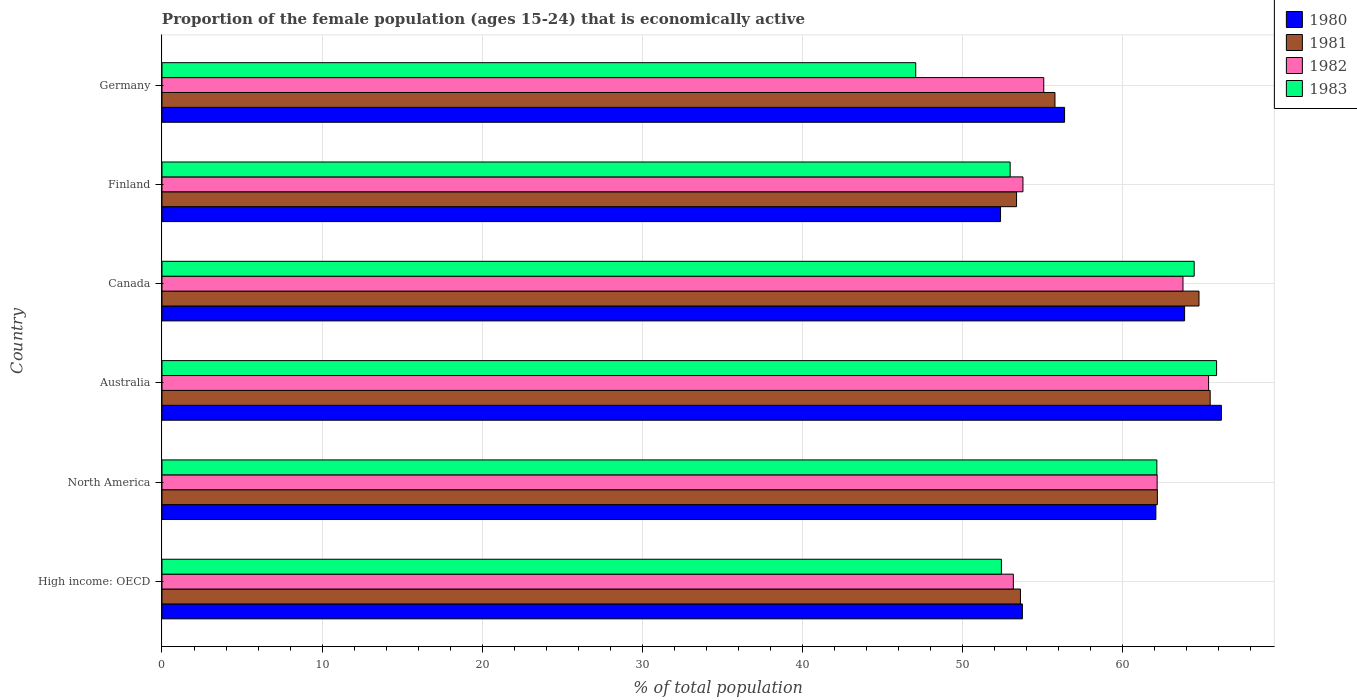How many different coloured bars are there?
Keep it short and to the point. 4. How many groups of bars are there?
Your response must be concise. 6. Are the number of bars per tick equal to the number of legend labels?
Offer a very short reply. Yes. How many bars are there on the 3rd tick from the bottom?
Your answer should be very brief. 4. What is the proportion of the female population that is economically active in 1981 in High income: OECD?
Ensure brevity in your answer.  53.64. Across all countries, what is the maximum proportion of the female population that is economically active in 1982?
Provide a succinct answer. 65.4. Across all countries, what is the minimum proportion of the female population that is economically active in 1983?
Ensure brevity in your answer.  47.1. In which country was the proportion of the female population that is economically active in 1981 maximum?
Provide a short and direct response. Australia. What is the total proportion of the female population that is economically active in 1983 in the graph?
Your answer should be very brief. 345.12. What is the difference between the proportion of the female population that is economically active in 1982 in Canada and that in Germany?
Your answer should be very brief. 8.7. What is the difference between the proportion of the female population that is economically active in 1982 in Finland and the proportion of the female population that is economically active in 1981 in Canada?
Ensure brevity in your answer.  -11. What is the average proportion of the female population that is economically active in 1981 per country?
Your answer should be compact. 59.22. What is the difference between the proportion of the female population that is economically active in 1981 and proportion of the female population that is economically active in 1982 in North America?
Offer a terse response. 0.01. In how many countries, is the proportion of the female population that is economically active in 1983 greater than 32 %?
Make the answer very short. 6. What is the ratio of the proportion of the female population that is economically active in 1980 in High income: OECD to that in North America?
Give a very brief answer. 0.87. What is the difference between the highest and the second highest proportion of the female population that is economically active in 1981?
Your answer should be very brief. 0.7. What is the difference between the highest and the lowest proportion of the female population that is economically active in 1981?
Your answer should be very brief. 12.1. In how many countries, is the proportion of the female population that is economically active in 1983 greater than the average proportion of the female population that is economically active in 1983 taken over all countries?
Provide a succinct answer. 3. What does the 2nd bar from the top in High income: OECD represents?
Your answer should be compact. 1982. How many bars are there?
Provide a succinct answer. 24. Are the values on the major ticks of X-axis written in scientific E-notation?
Provide a succinct answer. No. Does the graph contain any zero values?
Provide a short and direct response. No. What is the title of the graph?
Make the answer very short. Proportion of the female population (ages 15-24) that is economically active. Does "2001" appear as one of the legend labels in the graph?
Keep it short and to the point. No. What is the label or title of the X-axis?
Give a very brief answer. % of total population. What is the label or title of the Y-axis?
Provide a succinct answer. Country. What is the % of total population in 1980 in High income: OECD?
Provide a succinct answer. 53.76. What is the % of total population in 1981 in High income: OECD?
Your answer should be very brief. 53.64. What is the % of total population in 1982 in High income: OECD?
Give a very brief answer. 53.2. What is the % of total population of 1983 in High income: OECD?
Offer a very short reply. 52.45. What is the % of total population of 1980 in North America?
Offer a terse response. 62.11. What is the % of total population in 1981 in North America?
Provide a succinct answer. 62.2. What is the % of total population in 1982 in North America?
Ensure brevity in your answer.  62.19. What is the % of total population in 1983 in North America?
Give a very brief answer. 62.17. What is the % of total population of 1980 in Australia?
Your answer should be very brief. 66.2. What is the % of total population in 1981 in Australia?
Your response must be concise. 65.5. What is the % of total population in 1982 in Australia?
Offer a terse response. 65.4. What is the % of total population of 1983 in Australia?
Your answer should be very brief. 65.9. What is the % of total population in 1980 in Canada?
Give a very brief answer. 63.9. What is the % of total population of 1981 in Canada?
Your answer should be compact. 64.8. What is the % of total population of 1982 in Canada?
Provide a succinct answer. 63.8. What is the % of total population of 1983 in Canada?
Provide a succinct answer. 64.5. What is the % of total population in 1980 in Finland?
Provide a succinct answer. 52.4. What is the % of total population of 1981 in Finland?
Offer a very short reply. 53.4. What is the % of total population of 1982 in Finland?
Your answer should be very brief. 53.8. What is the % of total population in 1980 in Germany?
Offer a very short reply. 56.4. What is the % of total population of 1981 in Germany?
Give a very brief answer. 55.8. What is the % of total population in 1982 in Germany?
Offer a very short reply. 55.1. What is the % of total population of 1983 in Germany?
Ensure brevity in your answer.  47.1. Across all countries, what is the maximum % of total population in 1980?
Your answer should be very brief. 66.2. Across all countries, what is the maximum % of total population of 1981?
Ensure brevity in your answer.  65.5. Across all countries, what is the maximum % of total population of 1982?
Provide a succinct answer. 65.4. Across all countries, what is the maximum % of total population in 1983?
Make the answer very short. 65.9. Across all countries, what is the minimum % of total population in 1980?
Your answer should be very brief. 52.4. Across all countries, what is the minimum % of total population of 1981?
Make the answer very short. 53.4. Across all countries, what is the minimum % of total population of 1982?
Your answer should be compact. 53.2. Across all countries, what is the minimum % of total population of 1983?
Keep it short and to the point. 47.1. What is the total % of total population in 1980 in the graph?
Ensure brevity in your answer.  354.77. What is the total % of total population of 1981 in the graph?
Offer a terse response. 355.34. What is the total % of total population in 1982 in the graph?
Give a very brief answer. 353.48. What is the total % of total population in 1983 in the graph?
Your response must be concise. 345.12. What is the difference between the % of total population of 1980 in High income: OECD and that in North America?
Offer a terse response. -8.34. What is the difference between the % of total population of 1981 in High income: OECD and that in North America?
Make the answer very short. -8.56. What is the difference between the % of total population of 1982 in High income: OECD and that in North America?
Provide a short and direct response. -8.99. What is the difference between the % of total population of 1983 in High income: OECD and that in North America?
Ensure brevity in your answer.  -9.71. What is the difference between the % of total population in 1980 in High income: OECD and that in Australia?
Ensure brevity in your answer.  -12.44. What is the difference between the % of total population in 1981 in High income: OECD and that in Australia?
Your answer should be very brief. -11.86. What is the difference between the % of total population in 1982 in High income: OECD and that in Australia?
Offer a terse response. -12.2. What is the difference between the % of total population in 1983 in High income: OECD and that in Australia?
Provide a short and direct response. -13.45. What is the difference between the % of total population of 1980 in High income: OECD and that in Canada?
Ensure brevity in your answer.  -10.14. What is the difference between the % of total population in 1981 in High income: OECD and that in Canada?
Offer a terse response. -11.16. What is the difference between the % of total population in 1982 in High income: OECD and that in Canada?
Provide a short and direct response. -10.6. What is the difference between the % of total population in 1983 in High income: OECD and that in Canada?
Keep it short and to the point. -12.05. What is the difference between the % of total population of 1980 in High income: OECD and that in Finland?
Offer a very short reply. 1.36. What is the difference between the % of total population in 1981 in High income: OECD and that in Finland?
Offer a terse response. 0.24. What is the difference between the % of total population in 1982 in High income: OECD and that in Finland?
Give a very brief answer. -0.6. What is the difference between the % of total population in 1983 in High income: OECD and that in Finland?
Offer a very short reply. -0.55. What is the difference between the % of total population of 1980 in High income: OECD and that in Germany?
Your answer should be very brief. -2.64. What is the difference between the % of total population of 1981 in High income: OECD and that in Germany?
Provide a short and direct response. -2.16. What is the difference between the % of total population of 1982 in High income: OECD and that in Germany?
Ensure brevity in your answer.  -1.9. What is the difference between the % of total population in 1983 in High income: OECD and that in Germany?
Offer a terse response. 5.35. What is the difference between the % of total population in 1980 in North America and that in Australia?
Your answer should be very brief. -4.09. What is the difference between the % of total population in 1981 in North America and that in Australia?
Offer a very short reply. -3.3. What is the difference between the % of total population of 1982 in North America and that in Australia?
Provide a short and direct response. -3.21. What is the difference between the % of total population of 1983 in North America and that in Australia?
Provide a short and direct response. -3.73. What is the difference between the % of total population of 1980 in North America and that in Canada?
Your answer should be compact. -1.79. What is the difference between the % of total population in 1981 in North America and that in Canada?
Make the answer very short. -2.6. What is the difference between the % of total population of 1982 in North America and that in Canada?
Your response must be concise. -1.61. What is the difference between the % of total population of 1983 in North America and that in Canada?
Your answer should be very brief. -2.33. What is the difference between the % of total population in 1980 in North America and that in Finland?
Ensure brevity in your answer.  9.71. What is the difference between the % of total population in 1981 in North America and that in Finland?
Offer a very short reply. 8.8. What is the difference between the % of total population in 1982 in North America and that in Finland?
Your response must be concise. 8.39. What is the difference between the % of total population of 1983 in North America and that in Finland?
Provide a succinct answer. 9.17. What is the difference between the % of total population in 1980 in North America and that in Germany?
Your answer should be very brief. 5.71. What is the difference between the % of total population of 1981 in North America and that in Germany?
Make the answer very short. 6.4. What is the difference between the % of total population of 1982 in North America and that in Germany?
Your answer should be very brief. 7.09. What is the difference between the % of total population in 1983 in North America and that in Germany?
Offer a very short reply. 15.07. What is the difference between the % of total population in 1980 in Australia and that in Canada?
Offer a terse response. 2.3. What is the difference between the % of total population of 1982 in Australia and that in Canada?
Offer a terse response. 1.6. What is the difference between the % of total population in 1981 in Australia and that in Finland?
Ensure brevity in your answer.  12.1. What is the difference between the % of total population in 1982 in Australia and that in Finland?
Offer a terse response. 11.6. What is the difference between the % of total population in 1980 in Australia and that in Germany?
Keep it short and to the point. 9.8. What is the difference between the % of total population of 1983 in Australia and that in Germany?
Make the answer very short. 18.8. What is the difference between the % of total population in 1980 in Canada and that in Finland?
Ensure brevity in your answer.  11.5. What is the difference between the % of total population in 1983 in Canada and that in Finland?
Make the answer very short. 11.5. What is the difference between the % of total population of 1981 in Canada and that in Germany?
Make the answer very short. 9. What is the difference between the % of total population in 1982 in Canada and that in Germany?
Your answer should be compact. 8.7. What is the difference between the % of total population in 1983 in Canada and that in Germany?
Offer a terse response. 17.4. What is the difference between the % of total population of 1982 in Finland and that in Germany?
Make the answer very short. -1.3. What is the difference between the % of total population of 1980 in High income: OECD and the % of total population of 1981 in North America?
Keep it short and to the point. -8.44. What is the difference between the % of total population of 1980 in High income: OECD and the % of total population of 1982 in North America?
Provide a succinct answer. -8.42. What is the difference between the % of total population in 1980 in High income: OECD and the % of total population in 1983 in North America?
Keep it short and to the point. -8.4. What is the difference between the % of total population in 1981 in High income: OECD and the % of total population in 1982 in North America?
Ensure brevity in your answer.  -8.54. What is the difference between the % of total population of 1981 in High income: OECD and the % of total population of 1983 in North America?
Your answer should be compact. -8.52. What is the difference between the % of total population in 1982 in High income: OECD and the % of total population in 1983 in North America?
Keep it short and to the point. -8.97. What is the difference between the % of total population of 1980 in High income: OECD and the % of total population of 1981 in Australia?
Make the answer very short. -11.74. What is the difference between the % of total population of 1980 in High income: OECD and the % of total population of 1982 in Australia?
Offer a very short reply. -11.64. What is the difference between the % of total population of 1980 in High income: OECD and the % of total population of 1983 in Australia?
Keep it short and to the point. -12.14. What is the difference between the % of total population of 1981 in High income: OECD and the % of total population of 1982 in Australia?
Your answer should be compact. -11.76. What is the difference between the % of total population of 1981 in High income: OECD and the % of total population of 1983 in Australia?
Your answer should be very brief. -12.26. What is the difference between the % of total population in 1982 in High income: OECD and the % of total population in 1983 in Australia?
Offer a terse response. -12.7. What is the difference between the % of total population in 1980 in High income: OECD and the % of total population in 1981 in Canada?
Provide a short and direct response. -11.04. What is the difference between the % of total population in 1980 in High income: OECD and the % of total population in 1982 in Canada?
Your response must be concise. -10.04. What is the difference between the % of total population of 1980 in High income: OECD and the % of total population of 1983 in Canada?
Offer a terse response. -10.74. What is the difference between the % of total population in 1981 in High income: OECD and the % of total population in 1982 in Canada?
Give a very brief answer. -10.16. What is the difference between the % of total population in 1981 in High income: OECD and the % of total population in 1983 in Canada?
Ensure brevity in your answer.  -10.86. What is the difference between the % of total population in 1982 in High income: OECD and the % of total population in 1983 in Canada?
Your answer should be very brief. -11.3. What is the difference between the % of total population of 1980 in High income: OECD and the % of total population of 1981 in Finland?
Your answer should be compact. 0.36. What is the difference between the % of total population of 1980 in High income: OECD and the % of total population of 1982 in Finland?
Your answer should be very brief. -0.04. What is the difference between the % of total population in 1980 in High income: OECD and the % of total population in 1983 in Finland?
Provide a succinct answer. 0.76. What is the difference between the % of total population in 1981 in High income: OECD and the % of total population in 1982 in Finland?
Make the answer very short. -0.16. What is the difference between the % of total population in 1981 in High income: OECD and the % of total population in 1983 in Finland?
Provide a short and direct response. 0.64. What is the difference between the % of total population in 1982 in High income: OECD and the % of total population in 1983 in Finland?
Provide a short and direct response. 0.2. What is the difference between the % of total population in 1980 in High income: OECD and the % of total population in 1981 in Germany?
Offer a terse response. -2.04. What is the difference between the % of total population in 1980 in High income: OECD and the % of total population in 1982 in Germany?
Offer a terse response. -1.34. What is the difference between the % of total population in 1980 in High income: OECD and the % of total population in 1983 in Germany?
Give a very brief answer. 6.66. What is the difference between the % of total population of 1981 in High income: OECD and the % of total population of 1982 in Germany?
Give a very brief answer. -1.46. What is the difference between the % of total population of 1981 in High income: OECD and the % of total population of 1983 in Germany?
Ensure brevity in your answer.  6.54. What is the difference between the % of total population of 1982 in High income: OECD and the % of total population of 1983 in Germany?
Provide a short and direct response. 6.1. What is the difference between the % of total population in 1980 in North America and the % of total population in 1981 in Australia?
Provide a short and direct response. -3.39. What is the difference between the % of total population in 1980 in North America and the % of total population in 1982 in Australia?
Provide a succinct answer. -3.29. What is the difference between the % of total population in 1980 in North America and the % of total population in 1983 in Australia?
Provide a succinct answer. -3.79. What is the difference between the % of total population of 1981 in North America and the % of total population of 1982 in Australia?
Keep it short and to the point. -3.2. What is the difference between the % of total population in 1981 in North America and the % of total population in 1983 in Australia?
Offer a very short reply. -3.7. What is the difference between the % of total population in 1982 in North America and the % of total population in 1983 in Australia?
Provide a short and direct response. -3.71. What is the difference between the % of total population of 1980 in North America and the % of total population of 1981 in Canada?
Ensure brevity in your answer.  -2.69. What is the difference between the % of total population of 1980 in North America and the % of total population of 1982 in Canada?
Ensure brevity in your answer.  -1.69. What is the difference between the % of total population of 1980 in North America and the % of total population of 1983 in Canada?
Offer a terse response. -2.39. What is the difference between the % of total population in 1981 in North America and the % of total population in 1982 in Canada?
Your answer should be very brief. -1.6. What is the difference between the % of total population of 1981 in North America and the % of total population of 1983 in Canada?
Give a very brief answer. -2.3. What is the difference between the % of total population in 1982 in North America and the % of total population in 1983 in Canada?
Offer a terse response. -2.31. What is the difference between the % of total population in 1980 in North America and the % of total population in 1981 in Finland?
Your response must be concise. 8.71. What is the difference between the % of total population of 1980 in North America and the % of total population of 1982 in Finland?
Provide a succinct answer. 8.31. What is the difference between the % of total population in 1980 in North America and the % of total population in 1983 in Finland?
Provide a short and direct response. 9.11. What is the difference between the % of total population of 1981 in North America and the % of total population of 1982 in Finland?
Your response must be concise. 8.4. What is the difference between the % of total population in 1981 in North America and the % of total population in 1983 in Finland?
Offer a very short reply. 9.2. What is the difference between the % of total population of 1982 in North America and the % of total population of 1983 in Finland?
Ensure brevity in your answer.  9.19. What is the difference between the % of total population in 1980 in North America and the % of total population in 1981 in Germany?
Ensure brevity in your answer.  6.31. What is the difference between the % of total population in 1980 in North America and the % of total population in 1982 in Germany?
Offer a very short reply. 7.01. What is the difference between the % of total population of 1980 in North America and the % of total population of 1983 in Germany?
Your response must be concise. 15.01. What is the difference between the % of total population of 1981 in North America and the % of total population of 1982 in Germany?
Give a very brief answer. 7.1. What is the difference between the % of total population of 1981 in North America and the % of total population of 1983 in Germany?
Provide a short and direct response. 15.1. What is the difference between the % of total population in 1982 in North America and the % of total population in 1983 in Germany?
Keep it short and to the point. 15.09. What is the difference between the % of total population of 1981 in Australia and the % of total population of 1982 in Canada?
Provide a short and direct response. 1.7. What is the difference between the % of total population of 1981 in Australia and the % of total population of 1983 in Canada?
Give a very brief answer. 1. What is the difference between the % of total population in 1981 in Australia and the % of total population in 1982 in Finland?
Provide a short and direct response. 11.7. What is the difference between the % of total population of 1981 in Australia and the % of total population of 1983 in Finland?
Offer a very short reply. 12.5. What is the difference between the % of total population in 1982 in Australia and the % of total population in 1983 in Finland?
Provide a succinct answer. 12.4. What is the difference between the % of total population of 1980 in Australia and the % of total population of 1981 in Germany?
Your answer should be very brief. 10.4. What is the difference between the % of total population of 1981 in Australia and the % of total population of 1983 in Germany?
Give a very brief answer. 18.4. What is the difference between the % of total population of 1982 in Australia and the % of total population of 1983 in Germany?
Provide a short and direct response. 18.3. What is the difference between the % of total population of 1980 in Canada and the % of total population of 1981 in Finland?
Keep it short and to the point. 10.5. What is the difference between the % of total population of 1980 in Canada and the % of total population of 1982 in Finland?
Your answer should be very brief. 10.1. What is the difference between the % of total population in 1980 in Canada and the % of total population in 1983 in Finland?
Offer a terse response. 10.9. What is the difference between the % of total population in 1980 in Canada and the % of total population in 1982 in Germany?
Make the answer very short. 8.8. What is the difference between the % of total population in 1980 in Canada and the % of total population in 1983 in Germany?
Offer a very short reply. 16.8. What is the difference between the % of total population in 1981 in Canada and the % of total population in 1982 in Germany?
Your answer should be compact. 9.7. What is the difference between the % of total population of 1982 in Canada and the % of total population of 1983 in Germany?
Provide a succinct answer. 16.7. What is the difference between the % of total population in 1981 in Finland and the % of total population in 1983 in Germany?
Offer a very short reply. 6.3. What is the average % of total population of 1980 per country?
Ensure brevity in your answer.  59.13. What is the average % of total population of 1981 per country?
Offer a terse response. 59.22. What is the average % of total population of 1982 per country?
Your response must be concise. 58.91. What is the average % of total population in 1983 per country?
Your answer should be very brief. 57.52. What is the difference between the % of total population in 1980 and % of total population in 1981 in High income: OECD?
Give a very brief answer. 0.12. What is the difference between the % of total population in 1980 and % of total population in 1982 in High income: OECD?
Offer a terse response. 0.57. What is the difference between the % of total population in 1980 and % of total population in 1983 in High income: OECD?
Give a very brief answer. 1.31. What is the difference between the % of total population of 1981 and % of total population of 1982 in High income: OECD?
Offer a terse response. 0.44. What is the difference between the % of total population in 1981 and % of total population in 1983 in High income: OECD?
Offer a terse response. 1.19. What is the difference between the % of total population in 1982 and % of total population in 1983 in High income: OECD?
Make the answer very short. 0.75. What is the difference between the % of total population in 1980 and % of total population in 1981 in North America?
Keep it short and to the point. -0.09. What is the difference between the % of total population in 1980 and % of total population in 1982 in North America?
Ensure brevity in your answer.  -0.08. What is the difference between the % of total population in 1980 and % of total population in 1983 in North America?
Keep it short and to the point. -0.06. What is the difference between the % of total population in 1981 and % of total population in 1982 in North America?
Your response must be concise. 0.01. What is the difference between the % of total population in 1981 and % of total population in 1983 in North America?
Offer a terse response. 0.03. What is the difference between the % of total population in 1982 and % of total population in 1983 in North America?
Make the answer very short. 0.02. What is the difference between the % of total population in 1980 and % of total population in 1981 in Australia?
Provide a short and direct response. 0.7. What is the difference between the % of total population of 1980 and % of total population of 1982 in Australia?
Offer a terse response. 0.8. What is the difference between the % of total population of 1980 and % of total population of 1983 in Australia?
Provide a short and direct response. 0.3. What is the difference between the % of total population in 1981 and % of total population in 1982 in Australia?
Offer a terse response. 0.1. What is the difference between the % of total population of 1982 and % of total population of 1983 in Australia?
Keep it short and to the point. -0.5. What is the difference between the % of total population of 1980 and % of total population of 1981 in Canada?
Your answer should be very brief. -0.9. What is the difference between the % of total population in 1981 and % of total population in 1982 in Canada?
Make the answer very short. 1. What is the difference between the % of total population of 1981 and % of total population of 1983 in Canada?
Give a very brief answer. 0.3. What is the difference between the % of total population of 1982 and % of total population of 1983 in Canada?
Your response must be concise. -0.7. What is the difference between the % of total population of 1980 and % of total population of 1982 in Finland?
Provide a succinct answer. -1.4. What is the difference between the % of total population of 1981 and % of total population of 1982 in Finland?
Ensure brevity in your answer.  -0.4. What is the difference between the % of total population in 1981 and % of total population in 1983 in Finland?
Keep it short and to the point. 0.4. What is the difference between the % of total population of 1980 and % of total population of 1981 in Germany?
Your response must be concise. 0.6. What is the difference between the % of total population of 1980 and % of total population of 1982 in Germany?
Offer a very short reply. 1.3. What is the ratio of the % of total population of 1980 in High income: OECD to that in North America?
Your response must be concise. 0.87. What is the ratio of the % of total population in 1981 in High income: OECD to that in North America?
Ensure brevity in your answer.  0.86. What is the ratio of the % of total population in 1982 in High income: OECD to that in North America?
Ensure brevity in your answer.  0.86. What is the ratio of the % of total population of 1983 in High income: OECD to that in North America?
Make the answer very short. 0.84. What is the ratio of the % of total population of 1980 in High income: OECD to that in Australia?
Provide a short and direct response. 0.81. What is the ratio of the % of total population in 1981 in High income: OECD to that in Australia?
Keep it short and to the point. 0.82. What is the ratio of the % of total population in 1982 in High income: OECD to that in Australia?
Ensure brevity in your answer.  0.81. What is the ratio of the % of total population of 1983 in High income: OECD to that in Australia?
Offer a terse response. 0.8. What is the ratio of the % of total population of 1980 in High income: OECD to that in Canada?
Offer a very short reply. 0.84. What is the ratio of the % of total population of 1981 in High income: OECD to that in Canada?
Provide a short and direct response. 0.83. What is the ratio of the % of total population of 1982 in High income: OECD to that in Canada?
Your response must be concise. 0.83. What is the ratio of the % of total population of 1983 in High income: OECD to that in Canada?
Keep it short and to the point. 0.81. What is the ratio of the % of total population of 1980 in High income: OECD to that in Finland?
Provide a succinct answer. 1.03. What is the ratio of the % of total population in 1983 in High income: OECD to that in Finland?
Keep it short and to the point. 0.99. What is the ratio of the % of total population of 1980 in High income: OECD to that in Germany?
Your answer should be compact. 0.95. What is the ratio of the % of total population of 1981 in High income: OECD to that in Germany?
Offer a terse response. 0.96. What is the ratio of the % of total population of 1982 in High income: OECD to that in Germany?
Make the answer very short. 0.97. What is the ratio of the % of total population of 1983 in High income: OECD to that in Germany?
Your response must be concise. 1.11. What is the ratio of the % of total population in 1980 in North America to that in Australia?
Ensure brevity in your answer.  0.94. What is the ratio of the % of total population of 1981 in North America to that in Australia?
Offer a terse response. 0.95. What is the ratio of the % of total population in 1982 in North America to that in Australia?
Keep it short and to the point. 0.95. What is the ratio of the % of total population in 1983 in North America to that in Australia?
Offer a terse response. 0.94. What is the ratio of the % of total population of 1980 in North America to that in Canada?
Your answer should be very brief. 0.97. What is the ratio of the % of total population in 1981 in North America to that in Canada?
Your answer should be compact. 0.96. What is the ratio of the % of total population of 1982 in North America to that in Canada?
Provide a short and direct response. 0.97. What is the ratio of the % of total population in 1983 in North America to that in Canada?
Offer a terse response. 0.96. What is the ratio of the % of total population of 1980 in North America to that in Finland?
Your response must be concise. 1.19. What is the ratio of the % of total population in 1981 in North America to that in Finland?
Your response must be concise. 1.16. What is the ratio of the % of total population of 1982 in North America to that in Finland?
Provide a succinct answer. 1.16. What is the ratio of the % of total population of 1983 in North America to that in Finland?
Your answer should be compact. 1.17. What is the ratio of the % of total population of 1980 in North America to that in Germany?
Your answer should be very brief. 1.1. What is the ratio of the % of total population in 1981 in North America to that in Germany?
Provide a succinct answer. 1.11. What is the ratio of the % of total population of 1982 in North America to that in Germany?
Make the answer very short. 1.13. What is the ratio of the % of total population of 1983 in North America to that in Germany?
Your answer should be compact. 1.32. What is the ratio of the % of total population in 1980 in Australia to that in Canada?
Offer a terse response. 1.04. What is the ratio of the % of total population of 1981 in Australia to that in Canada?
Keep it short and to the point. 1.01. What is the ratio of the % of total population in 1982 in Australia to that in Canada?
Keep it short and to the point. 1.03. What is the ratio of the % of total population in 1983 in Australia to that in Canada?
Ensure brevity in your answer.  1.02. What is the ratio of the % of total population in 1980 in Australia to that in Finland?
Make the answer very short. 1.26. What is the ratio of the % of total population of 1981 in Australia to that in Finland?
Give a very brief answer. 1.23. What is the ratio of the % of total population of 1982 in Australia to that in Finland?
Make the answer very short. 1.22. What is the ratio of the % of total population of 1983 in Australia to that in Finland?
Offer a terse response. 1.24. What is the ratio of the % of total population in 1980 in Australia to that in Germany?
Your answer should be very brief. 1.17. What is the ratio of the % of total population in 1981 in Australia to that in Germany?
Give a very brief answer. 1.17. What is the ratio of the % of total population of 1982 in Australia to that in Germany?
Offer a very short reply. 1.19. What is the ratio of the % of total population in 1983 in Australia to that in Germany?
Keep it short and to the point. 1.4. What is the ratio of the % of total population of 1980 in Canada to that in Finland?
Provide a succinct answer. 1.22. What is the ratio of the % of total population of 1981 in Canada to that in Finland?
Your answer should be very brief. 1.21. What is the ratio of the % of total population in 1982 in Canada to that in Finland?
Your response must be concise. 1.19. What is the ratio of the % of total population of 1983 in Canada to that in Finland?
Provide a short and direct response. 1.22. What is the ratio of the % of total population in 1980 in Canada to that in Germany?
Make the answer very short. 1.13. What is the ratio of the % of total population in 1981 in Canada to that in Germany?
Your response must be concise. 1.16. What is the ratio of the % of total population in 1982 in Canada to that in Germany?
Your response must be concise. 1.16. What is the ratio of the % of total population of 1983 in Canada to that in Germany?
Your answer should be compact. 1.37. What is the ratio of the % of total population of 1980 in Finland to that in Germany?
Your answer should be compact. 0.93. What is the ratio of the % of total population of 1982 in Finland to that in Germany?
Your response must be concise. 0.98. What is the ratio of the % of total population of 1983 in Finland to that in Germany?
Your answer should be very brief. 1.13. What is the difference between the highest and the second highest % of total population in 1980?
Keep it short and to the point. 2.3. What is the difference between the highest and the second highest % of total population of 1981?
Provide a short and direct response. 0.7. What is the difference between the highest and the second highest % of total population of 1982?
Offer a very short reply. 1.6. What is the difference between the highest and the lowest % of total population of 1981?
Provide a succinct answer. 12.1. What is the difference between the highest and the lowest % of total population of 1982?
Provide a succinct answer. 12.2. 